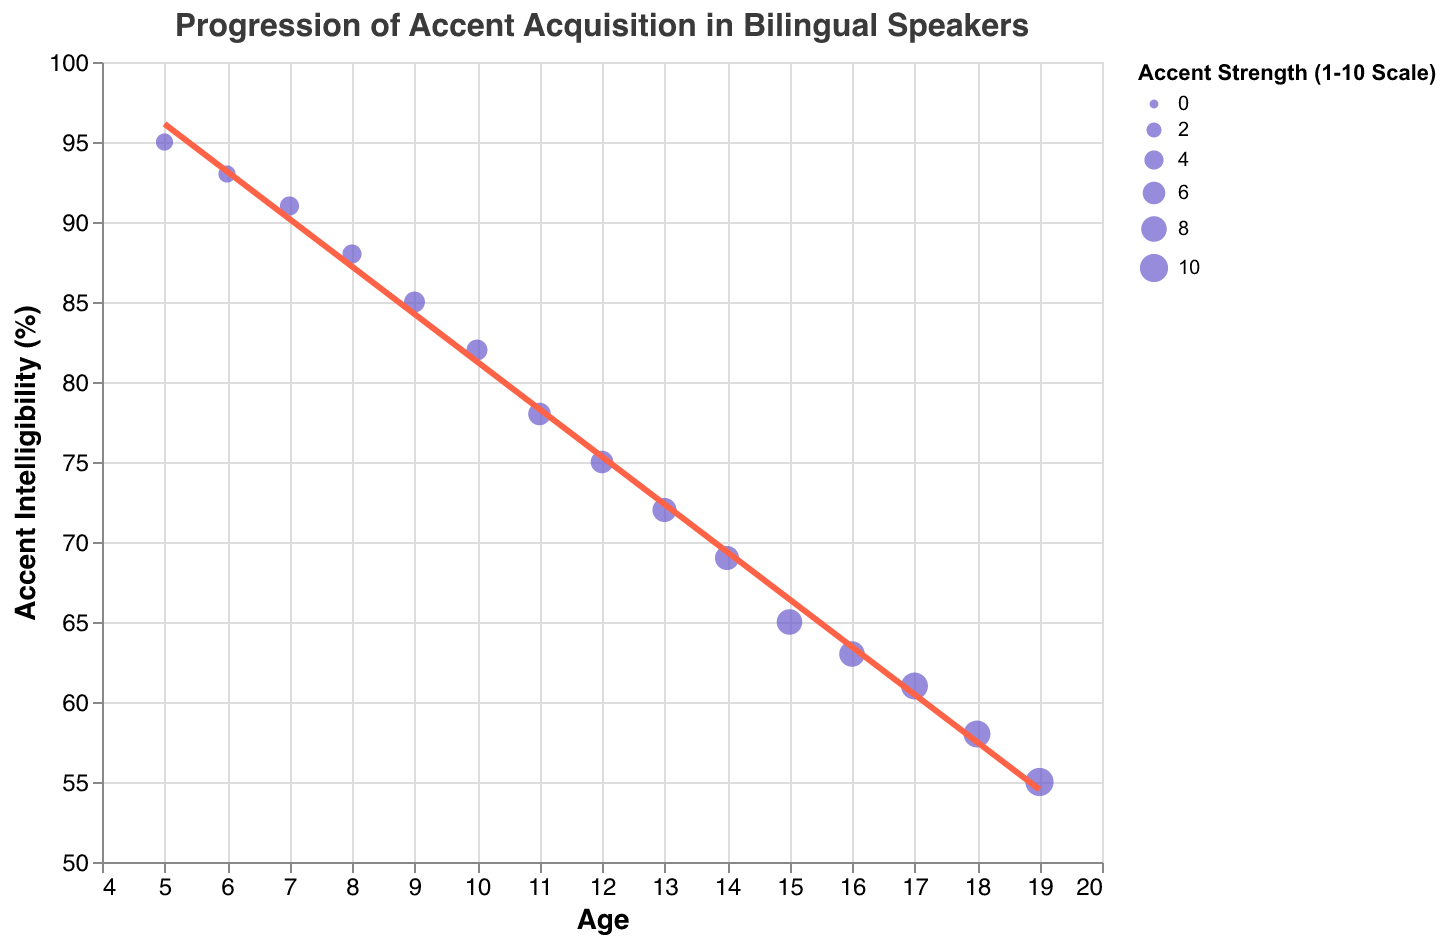What is the general trend in accent intelligibility from childhood to adulthood? The figure shows a scatter plot with a trend line. As the age increases from childhood to adulthood, the trend line for accent intelligibility (%) descends, indicating a general decrease in intelligibility over time.
Answer: It decreases At what age is accent intelligibility highest? By observing the y-axis value for "Accent Intelligibility (%)" and identifying the highest point, the highest accent intelligibility occurs at age 5 with a value of 95%.
Answer: 5 What is the relationship between accent strength and age? The figure reveals that as age increases from 5 to 19, the Accent Strength (1-10 Scale) also increases, which is evident from the size of the points increasing gradually over this age range.
Answer: It increases How does the trend line depict the relation between age and accent intelligibility? The trend line in the scatter plot shows a negative correlation between age and accent intelligibility, as it slopes downward, indicating that intelligibility decreases as age increases.
Answer: Negative correlation Which age group has the most significant decrease in accent intelligibility compared to the previous age group? By examining the points on the scatter plot, the most significant decrease in accent intelligibility occurs between ages 11 and 12, where it drops from 78% to 75%.
Answer: Ages 11 to 12 What's the average accent intelligibility for the age group 13 to 15? To find the average, we sum the intelligibility percentages for ages 13, 14, and 15 (72 + 69 + 65) and divide by 3. 72 + 69 + 65 = 206, and 206/3 = 68.67.
Answer: 68.67 Compare the accent strength at ages 8 and 16. Which age has a higher value? The figure shows accent strength on a scale of 1 to 10. At age 8, the strength is 4, and at age 16, it is 8, indicating that the accent strength is higher at age 16.
Answer: Age 16 What is the difference in accent intelligibility between ages 10 and 18? To find the difference, subtract the intelligibility percentage at age 18 from that at age 10 (82 - 58). 82 - 58 = 24.
Answer: 24 Is there any age where the accent strength plateau (remains the same) for consecutive years? By reviewing the data points for accent strength, between the ages of 5 and 6, both ages have a strength value of 3, indicating a plateau.
Answer: Ages 5 and 6 